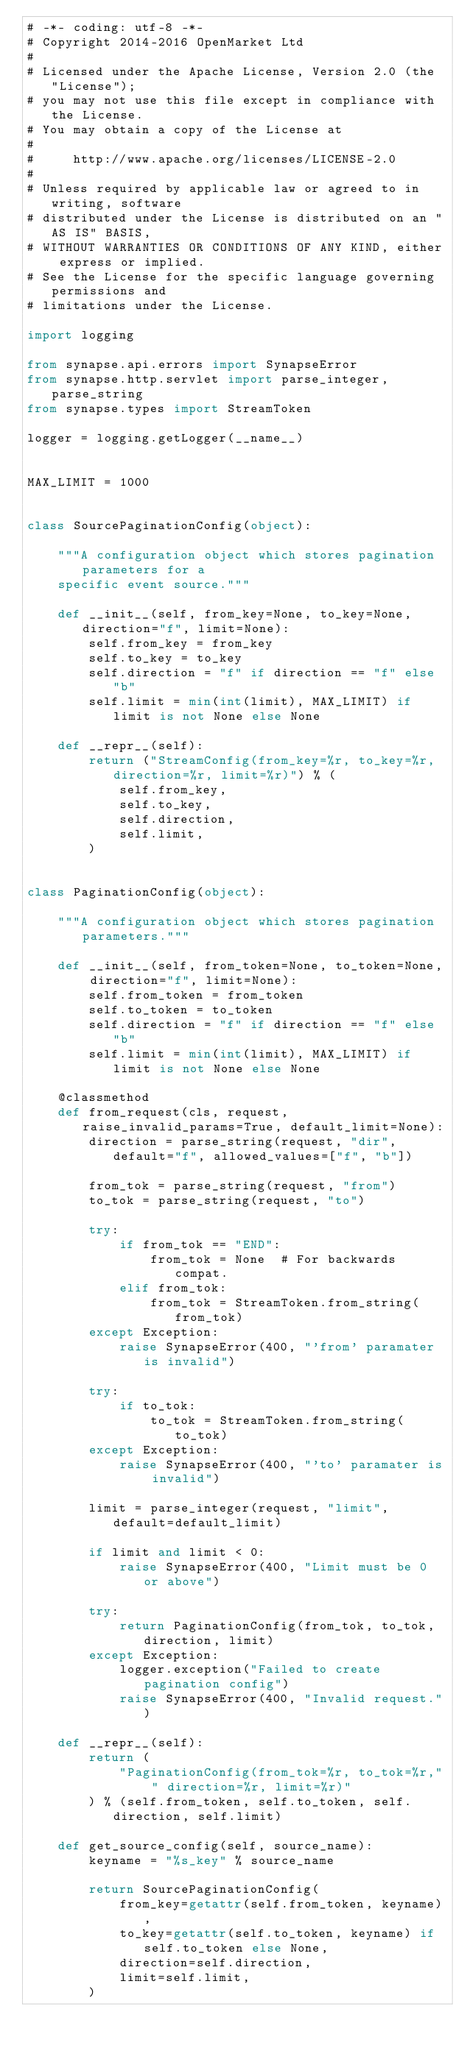<code> <loc_0><loc_0><loc_500><loc_500><_Python_># -*- coding: utf-8 -*-
# Copyright 2014-2016 OpenMarket Ltd
#
# Licensed under the Apache License, Version 2.0 (the "License");
# you may not use this file except in compliance with the License.
# You may obtain a copy of the License at
#
#     http://www.apache.org/licenses/LICENSE-2.0
#
# Unless required by applicable law or agreed to in writing, software
# distributed under the License is distributed on an "AS IS" BASIS,
# WITHOUT WARRANTIES OR CONDITIONS OF ANY KIND, either express or implied.
# See the License for the specific language governing permissions and
# limitations under the License.

import logging

from synapse.api.errors import SynapseError
from synapse.http.servlet import parse_integer, parse_string
from synapse.types import StreamToken

logger = logging.getLogger(__name__)


MAX_LIMIT = 1000


class SourcePaginationConfig(object):

    """A configuration object which stores pagination parameters for a
    specific event source."""

    def __init__(self, from_key=None, to_key=None, direction="f", limit=None):
        self.from_key = from_key
        self.to_key = to_key
        self.direction = "f" if direction == "f" else "b"
        self.limit = min(int(limit), MAX_LIMIT) if limit is not None else None

    def __repr__(self):
        return ("StreamConfig(from_key=%r, to_key=%r, direction=%r, limit=%r)") % (
            self.from_key,
            self.to_key,
            self.direction,
            self.limit,
        )


class PaginationConfig(object):

    """A configuration object which stores pagination parameters."""

    def __init__(self, from_token=None, to_token=None, direction="f", limit=None):
        self.from_token = from_token
        self.to_token = to_token
        self.direction = "f" if direction == "f" else "b"
        self.limit = min(int(limit), MAX_LIMIT) if limit is not None else None

    @classmethod
    def from_request(cls, request, raise_invalid_params=True, default_limit=None):
        direction = parse_string(request, "dir", default="f", allowed_values=["f", "b"])

        from_tok = parse_string(request, "from")
        to_tok = parse_string(request, "to")

        try:
            if from_tok == "END":
                from_tok = None  # For backwards compat.
            elif from_tok:
                from_tok = StreamToken.from_string(from_tok)
        except Exception:
            raise SynapseError(400, "'from' paramater is invalid")

        try:
            if to_tok:
                to_tok = StreamToken.from_string(to_tok)
        except Exception:
            raise SynapseError(400, "'to' paramater is invalid")

        limit = parse_integer(request, "limit", default=default_limit)

        if limit and limit < 0:
            raise SynapseError(400, "Limit must be 0 or above")

        try:
            return PaginationConfig(from_tok, to_tok, direction, limit)
        except Exception:
            logger.exception("Failed to create pagination config")
            raise SynapseError(400, "Invalid request.")

    def __repr__(self):
        return (
            "PaginationConfig(from_tok=%r, to_tok=%r," " direction=%r, limit=%r)"
        ) % (self.from_token, self.to_token, self.direction, self.limit)

    def get_source_config(self, source_name):
        keyname = "%s_key" % source_name

        return SourcePaginationConfig(
            from_key=getattr(self.from_token, keyname),
            to_key=getattr(self.to_token, keyname) if self.to_token else None,
            direction=self.direction,
            limit=self.limit,
        )
</code> 